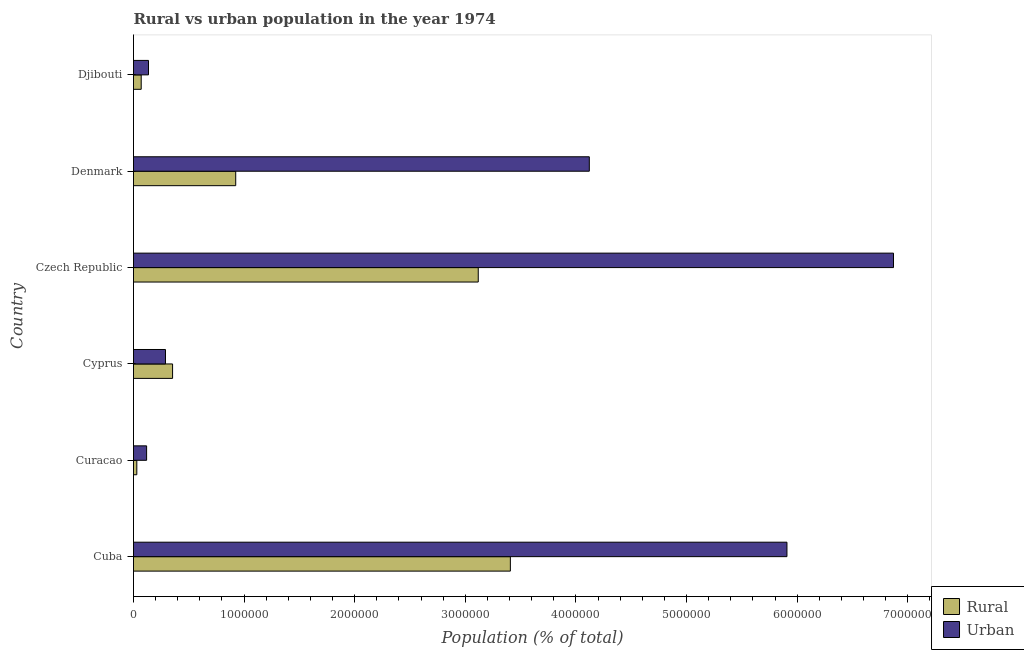How many different coloured bars are there?
Give a very brief answer. 2. Are the number of bars per tick equal to the number of legend labels?
Make the answer very short. Yes. Are the number of bars on each tick of the Y-axis equal?
Your response must be concise. Yes. How many bars are there on the 4th tick from the top?
Keep it short and to the point. 2. How many bars are there on the 5th tick from the bottom?
Offer a terse response. 2. What is the label of the 6th group of bars from the top?
Your response must be concise. Cuba. What is the urban population density in Denmark?
Offer a terse response. 4.12e+06. Across all countries, what is the maximum rural population density?
Ensure brevity in your answer.  3.41e+06. Across all countries, what is the minimum rural population density?
Offer a terse response. 2.99e+04. In which country was the rural population density maximum?
Provide a succinct answer. Cuba. In which country was the rural population density minimum?
Ensure brevity in your answer.  Curacao. What is the total rural population density in the graph?
Make the answer very short. 7.90e+06. What is the difference between the urban population density in Czech Republic and that in Djibouti?
Ensure brevity in your answer.  6.74e+06. What is the difference between the urban population density in Cyprus and the rural population density in Denmark?
Offer a very short reply. -6.35e+05. What is the average rural population density per country?
Offer a very short reply. 1.32e+06. What is the difference between the rural population density and urban population density in Denmark?
Provide a short and direct response. -3.20e+06. In how many countries, is the urban population density greater than 3600000 %?
Keep it short and to the point. 3. What is the ratio of the urban population density in Cuba to that in Djibouti?
Offer a terse response. 43.57. Is the difference between the urban population density in Cuba and Denmark greater than the difference between the rural population density in Cuba and Denmark?
Your answer should be compact. No. What is the difference between the highest and the second highest rural population density?
Ensure brevity in your answer.  2.90e+05. What is the difference between the highest and the lowest urban population density?
Offer a very short reply. 6.75e+06. What does the 2nd bar from the top in Djibouti represents?
Provide a short and direct response. Rural. What does the 2nd bar from the bottom in Curacao represents?
Your answer should be compact. Urban. How many bars are there?
Give a very brief answer. 12. Are all the bars in the graph horizontal?
Your response must be concise. Yes. How many countries are there in the graph?
Your answer should be very brief. 6. What is the difference between two consecutive major ticks on the X-axis?
Make the answer very short. 1.00e+06. Does the graph contain grids?
Your response must be concise. No. Where does the legend appear in the graph?
Your response must be concise. Bottom right. How many legend labels are there?
Keep it short and to the point. 2. What is the title of the graph?
Provide a short and direct response. Rural vs urban population in the year 1974. What is the label or title of the X-axis?
Make the answer very short. Population (% of total). What is the Population (% of total) in Rural in Cuba?
Your answer should be very brief. 3.41e+06. What is the Population (% of total) in Urban in Cuba?
Provide a short and direct response. 5.91e+06. What is the Population (% of total) of Rural in Curacao?
Provide a short and direct response. 2.99e+04. What is the Population (% of total) in Urban in Curacao?
Your response must be concise. 1.18e+05. What is the Population (% of total) in Rural in Cyprus?
Provide a short and direct response. 3.53e+05. What is the Population (% of total) in Urban in Cyprus?
Provide a succinct answer. 2.89e+05. What is the Population (% of total) of Rural in Czech Republic?
Keep it short and to the point. 3.12e+06. What is the Population (% of total) of Urban in Czech Republic?
Ensure brevity in your answer.  6.87e+06. What is the Population (% of total) in Rural in Denmark?
Provide a short and direct response. 9.24e+05. What is the Population (% of total) in Urban in Denmark?
Provide a short and direct response. 4.12e+06. What is the Population (% of total) of Rural in Djibouti?
Provide a short and direct response. 6.96e+04. What is the Population (% of total) of Urban in Djibouti?
Offer a very short reply. 1.36e+05. Across all countries, what is the maximum Population (% of total) in Rural?
Ensure brevity in your answer.  3.41e+06. Across all countries, what is the maximum Population (% of total) of Urban?
Keep it short and to the point. 6.87e+06. Across all countries, what is the minimum Population (% of total) of Rural?
Your response must be concise. 2.99e+04. Across all countries, what is the minimum Population (% of total) in Urban?
Your response must be concise. 1.18e+05. What is the total Population (% of total) in Rural in the graph?
Offer a terse response. 7.90e+06. What is the total Population (% of total) in Urban in the graph?
Offer a very short reply. 1.74e+07. What is the difference between the Population (% of total) in Rural in Cuba and that in Curacao?
Keep it short and to the point. 3.38e+06. What is the difference between the Population (% of total) of Urban in Cuba and that in Curacao?
Your answer should be very brief. 5.79e+06. What is the difference between the Population (% of total) of Rural in Cuba and that in Cyprus?
Provide a succinct answer. 3.05e+06. What is the difference between the Population (% of total) in Urban in Cuba and that in Cyprus?
Ensure brevity in your answer.  5.62e+06. What is the difference between the Population (% of total) in Rural in Cuba and that in Czech Republic?
Your answer should be very brief. 2.90e+05. What is the difference between the Population (% of total) of Urban in Cuba and that in Czech Republic?
Make the answer very short. -9.63e+05. What is the difference between the Population (% of total) of Rural in Cuba and that in Denmark?
Offer a terse response. 2.48e+06. What is the difference between the Population (% of total) in Urban in Cuba and that in Denmark?
Provide a short and direct response. 1.79e+06. What is the difference between the Population (% of total) of Rural in Cuba and that in Djibouti?
Provide a short and direct response. 3.34e+06. What is the difference between the Population (% of total) in Urban in Cuba and that in Djibouti?
Your answer should be compact. 5.77e+06. What is the difference between the Population (% of total) of Rural in Curacao and that in Cyprus?
Ensure brevity in your answer.  -3.23e+05. What is the difference between the Population (% of total) of Urban in Curacao and that in Cyprus?
Offer a terse response. -1.71e+05. What is the difference between the Population (% of total) in Rural in Curacao and that in Czech Republic?
Ensure brevity in your answer.  -3.09e+06. What is the difference between the Population (% of total) in Urban in Curacao and that in Czech Republic?
Keep it short and to the point. -6.75e+06. What is the difference between the Population (% of total) of Rural in Curacao and that in Denmark?
Give a very brief answer. -8.94e+05. What is the difference between the Population (% of total) in Urban in Curacao and that in Denmark?
Provide a short and direct response. -4.00e+06. What is the difference between the Population (% of total) of Rural in Curacao and that in Djibouti?
Offer a terse response. -3.96e+04. What is the difference between the Population (% of total) in Urban in Curacao and that in Djibouti?
Your answer should be compact. -1.72e+04. What is the difference between the Population (% of total) in Rural in Cyprus and that in Czech Republic?
Make the answer very short. -2.76e+06. What is the difference between the Population (% of total) in Urban in Cyprus and that in Czech Republic?
Your answer should be very brief. -6.58e+06. What is the difference between the Population (% of total) in Rural in Cyprus and that in Denmark?
Your answer should be compact. -5.71e+05. What is the difference between the Population (% of total) in Urban in Cyprus and that in Denmark?
Offer a very short reply. -3.83e+06. What is the difference between the Population (% of total) in Rural in Cyprus and that in Djibouti?
Provide a succinct answer. 2.84e+05. What is the difference between the Population (% of total) of Urban in Cyprus and that in Djibouti?
Provide a short and direct response. 1.53e+05. What is the difference between the Population (% of total) in Rural in Czech Republic and that in Denmark?
Keep it short and to the point. 2.19e+06. What is the difference between the Population (% of total) of Urban in Czech Republic and that in Denmark?
Provide a short and direct response. 2.75e+06. What is the difference between the Population (% of total) in Rural in Czech Republic and that in Djibouti?
Make the answer very short. 3.05e+06. What is the difference between the Population (% of total) of Urban in Czech Republic and that in Djibouti?
Keep it short and to the point. 6.74e+06. What is the difference between the Population (% of total) of Rural in Denmark and that in Djibouti?
Make the answer very short. 8.55e+05. What is the difference between the Population (% of total) in Urban in Denmark and that in Djibouti?
Provide a succinct answer. 3.99e+06. What is the difference between the Population (% of total) of Rural in Cuba and the Population (% of total) of Urban in Curacao?
Make the answer very short. 3.29e+06. What is the difference between the Population (% of total) in Rural in Cuba and the Population (% of total) in Urban in Cyprus?
Offer a terse response. 3.12e+06. What is the difference between the Population (% of total) in Rural in Cuba and the Population (% of total) in Urban in Czech Republic?
Your response must be concise. -3.46e+06. What is the difference between the Population (% of total) in Rural in Cuba and the Population (% of total) in Urban in Denmark?
Provide a short and direct response. -7.14e+05. What is the difference between the Population (% of total) in Rural in Cuba and the Population (% of total) in Urban in Djibouti?
Your response must be concise. 3.27e+06. What is the difference between the Population (% of total) in Rural in Curacao and the Population (% of total) in Urban in Cyprus?
Provide a short and direct response. -2.59e+05. What is the difference between the Population (% of total) in Rural in Curacao and the Population (% of total) in Urban in Czech Republic?
Offer a very short reply. -6.84e+06. What is the difference between the Population (% of total) in Rural in Curacao and the Population (% of total) in Urban in Denmark?
Offer a terse response. -4.09e+06. What is the difference between the Population (% of total) of Rural in Curacao and the Population (% of total) of Urban in Djibouti?
Provide a short and direct response. -1.06e+05. What is the difference between the Population (% of total) in Rural in Cyprus and the Population (% of total) in Urban in Czech Republic?
Keep it short and to the point. -6.52e+06. What is the difference between the Population (% of total) of Rural in Cyprus and the Population (% of total) of Urban in Denmark?
Give a very brief answer. -3.77e+06. What is the difference between the Population (% of total) of Rural in Cyprus and the Population (% of total) of Urban in Djibouti?
Keep it short and to the point. 2.18e+05. What is the difference between the Population (% of total) of Rural in Czech Republic and the Population (% of total) of Urban in Denmark?
Your answer should be compact. -1.00e+06. What is the difference between the Population (% of total) in Rural in Czech Republic and the Population (% of total) in Urban in Djibouti?
Your answer should be compact. 2.98e+06. What is the difference between the Population (% of total) of Rural in Denmark and the Population (% of total) of Urban in Djibouti?
Your answer should be very brief. 7.89e+05. What is the average Population (% of total) in Rural per country?
Keep it short and to the point. 1.32e+06. What is the average Population (% of total) in Urban per country?
Offer a very short reply. 2.91e+06. What is the difference between the Population (% of total) of Rural and Population (% of total) of Urban in Cuba?
Provide a succinct answer. -2.50e+06. What is the difference between the Population (% of total) of Rural and Population (% of total) of Urban in Curacao?
Offer a very short reply. -8.85e+04. What is the difference between the Population (% of total) of Rural and Population (% of total) of Urban in Cyprus?
Your answer should be very brief. 6.41e+04. What is the difference between the Population (% of total) of Rural and Population (% of total) of Urban in Czech Republic?
Your answer should be compact. -3.75e+06. What is the difference between the Population (% of total) of Rural and Population (% of total) of Urban in Denmark?
Ensure brevity in your answer.  -3.20e+06. What is the difference between the Population (% of total) in Rural and Population (% of total) in Urban in Djibouti?
Ensure brevity in your answer.  -6.61e+04. What is the ratio of the Population (% of total) in Rural in Cuba to that in Curacao?
Offer a very short reply. 113.85. What is the ratio of the Population (% of total) of Urban in Cuba to that in Curacao?
Ensure brevity in your answer.  49.89. What is the ratio of the Population (% of total) of Rural in Cuba to that in Cyprus?
Offer a very short reply. 9.65. What is the ratio of the Population (% of total) in Urban in Cuba to that in Cyprus?
Offer a terse response. 20.44. What is the ratio of the Population (% of total) in Rural in Cuba to that in Czech Republic?
Give a very brief answer. 1.09. What is the ratio of the Population (% of total) in Urban in Cuba to that in Czech Republic?
Your answer should be very brief. 0.86. What is the ratio of the Population (% of total) of Rural in Cuba to that in Denmark?
Your response must be concise. 3.69. What is the ratio of the Population (% of total) of Urban in Cuba to that in Denmark?
Keep it short and to the point. 1.43. What is the ratio of the Population (% of total) of Rural in Cuba to that in Djibouti?
Keep it short and to the point. 48.99. What is the ratio of the Population (% of total) in Urban in Cuba to that in Djibouti?
Make the answer very short. 43.57. What is the ratio of the Population (% of total) in Rural in Curacao to that in Cyprus?
Offer a very short reply. 0.08. What is the ratio of the Population (% of total) of Urban in Curacao to that in Cyprus?
Your response must be concise. 0.41. What is the ratio of the Population (% of total) of Rural in Curacao to that in Czech Republic?
Ensure brevity in your answer.  0.01. What is the ratio of the Population (% of total) of Urban in Curacao to that in Czech Republic?
Offer a terse response. 0.02. What is the ratio of the Population (% of total) of Rural in Curacao to that in Denmark?
Provide a succinct answer. 0.03. What is the ratio of the Population (% of total) in Urban in Curacao to that in Denmark?
Your answer should be very brief. 0.03. What is the ratio of the Population (% of total) in Rural in Curacao to that in Djibouti?
Offer a terse response. 0.43. What is the ratio of the Population (% of total) of Urban in Curacao to that in Djibouti?
Your response must be concise. 0.87. What is the ratio of the Population (% of total) in Rural in Cyprus to that in Czech Republic?
Give a very brief answer. 0.11. What is the ratio of the Population (% of total) of Urban in Cyprus to that in Czech Republic?
Give a very brief answer. 0.04. What is the ratio of the Population (% of total) in Rural in Cyprus to that in Denmark?
Ensure brevity in your answer.  0.38. What is the ratio of the Population (% of total) in Urban in Cyprus to that in Denmark?
Give a very brief answer. 0.07. What is the ratio of the Population (% of total) of Rural in Cyprus to that in Djibouti?
Give a very brief answer. 5.08. What is the ratio of the Population (% of total) in Urban in Cyprus to that in Djibouti?
Make the answer very short. 2.13. What is the ratio of the Population (% of total) of Rural in Czech Republic to that in Denmark?
Keep it short and to the point. 3.37. What is the ratio of the Population (% of total) of Urban in Czech Republic to that in Denmark?
Your response must be concise. 1.67. What is the ratio of the Population (% of total) of Rural in Czech Republic to that in Djibouti?
Your answer should be compact. 44.82. What is the ratio of the Population (% of total) of Urban in Czech Republic to that in Djibouti?
Keep it short and to the point. 50.67. What is the ratio of the Population (% of total) of Rural in Denmark to that in Djibouti?
Give a very brief answer. 13.29. What is the ratio of the Population (% of total) in Urban in Denmark to that in Djibouti?
Offer a very short reply. 30.39. What is the difference between the highest and the second highest Population (% of total) of Rural?
Ensure brevity in your answer.  2.90e+05. What is the difference between the highest and the second highest Population (% of total) of Urban?
Provide a short and direct response. 9.63e+05. What is the difference between the highest and the lowest Population (% of total) of Rural?
Your response must be concise. 3.38e+06. What is the difference between the highest and the lowest Population (% of total) in Urban?
Give a very brief answer. 6.75e+06. 